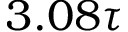Convert formula to latex. <formula><loc_0><loc_0><loc_500><loc_500>3 . 0 8 \tau</formula> 